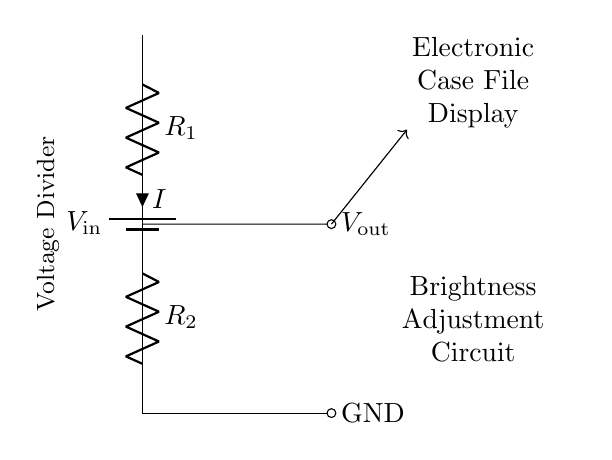What is the input voltage in the circuit? The input voltage is labeled as V_in at the top of the circuit diagram, indicating where the voltage is supplied to the circuit.
Answer: V_in What are the two types of components used in the circuit? The circuit consists of a battery and two resistors. The battery represents the power source, while the resistors are used for dividing the voltage.
Answer: Battery and resistors What is the output voltage node labeled as? The output voltage is indicated as V_out, showing the point where the adjusted voltage is taken from the circuit for the electronic case file display.
Answer: V_out How does the current flow through the resistors? The current flows from the battery into R_1, through R_2, and then to ground. The series connection implies that the same current I flows through both resistors in this voltage divider setup.
Answer: From battery through R_1 and R_2 to ground What is the purpose of this circuit? The purpose of this circuit is to adjust the brightness of the electronic case file display by controlling the output voltage using the voltage divider effect of the resistors.
Answer: Brightness adjustment What is the relationship between R_1 and R_2 for voltage division? The output voltage V_out is proportional to R_2 in relation to the total resistance (R_1 + R_2), following the voltage divider rule: V_out = V_in * (R_2 / (R_1 + R_2)).
Answer: V_out = V_in * (R_2 / (R_1 + R_2)) Which component primarily determines the brightness adjustment of the display? R_2 primarily determines the brightness adjustment as it influences the output voltage that ultimately controls the brightness of the electronic case file display.
Answer: R_2 